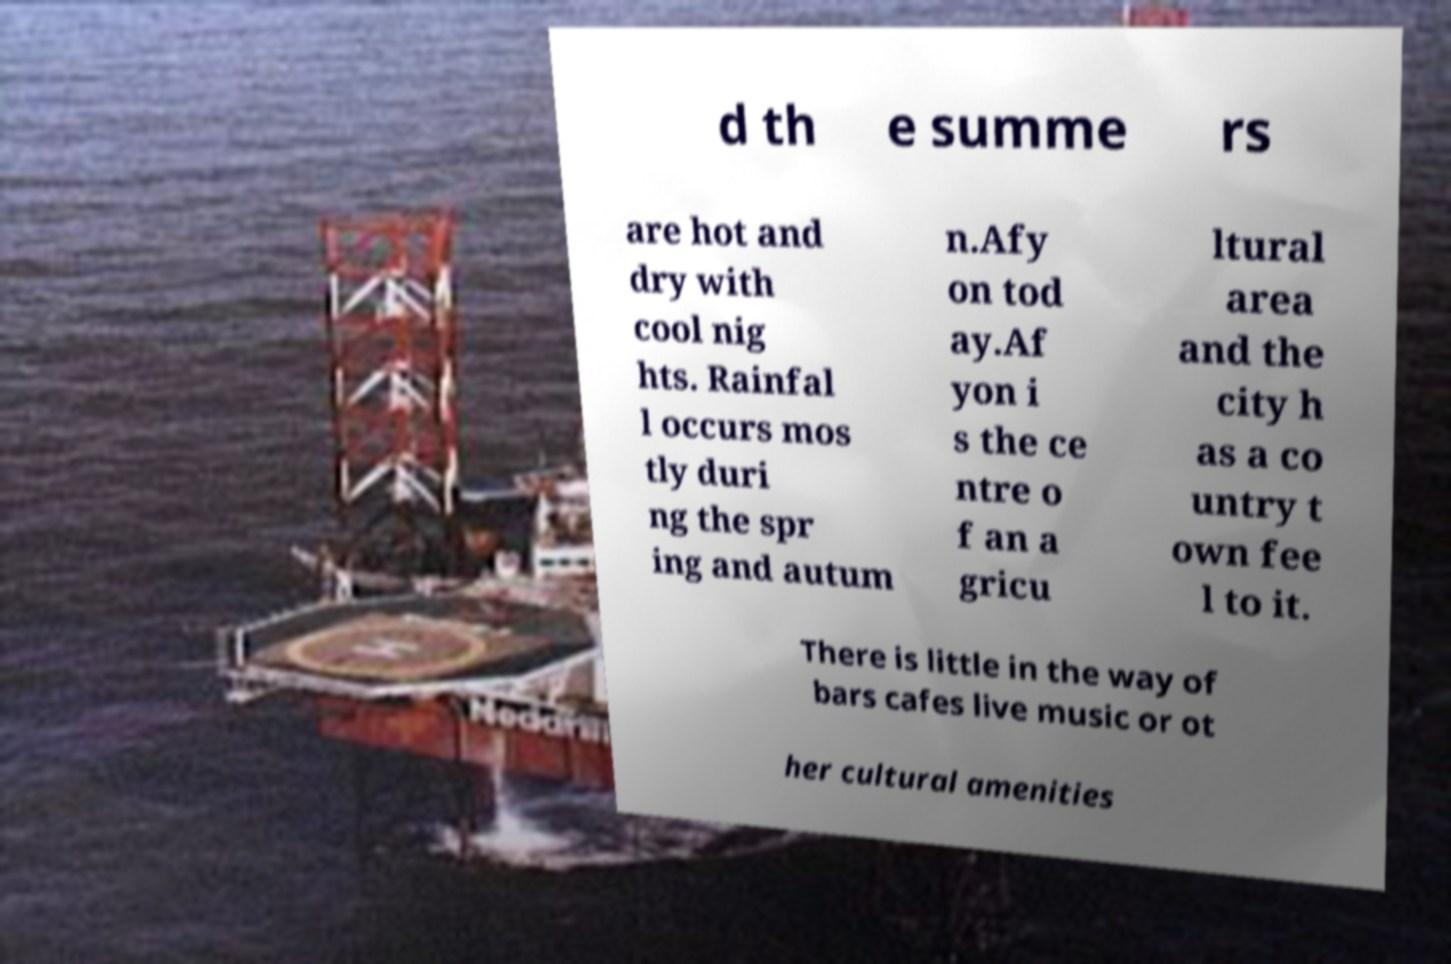There's text embedded in this image that I need extracted. Can you transcribe it verbatim? d th e summe rs are hot and dry with cool nig hts. Rainfal l occurs mos tly duri ng the spr ing and autum n.Afy on tod ay.Af yon i s the ce ntre o f an a gricu ltural area and the city h as a co untry t own fee l to it. There is little in the way of bars cafes live music or ot her cultural amenities 